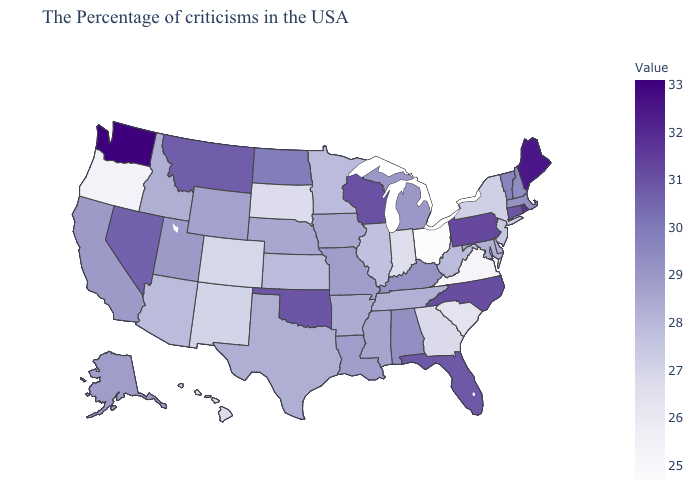Among the states that border Wisconsin , which have the lowest value?
Short answer required. Illinois. Does the map have missing data?
Concise answer only. No. Does Iowa have a higher value than Colorado?
Answer briefly. Yes. 